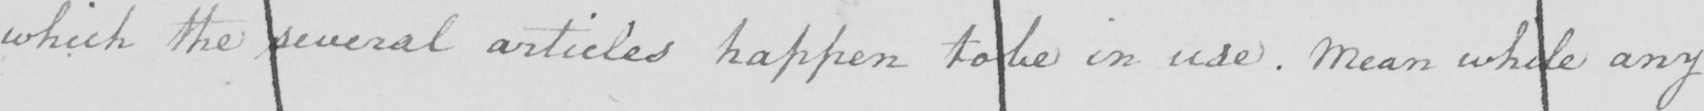Please provide the text content of this handwritten line. which the several articles happen to be in use. Mean while any 